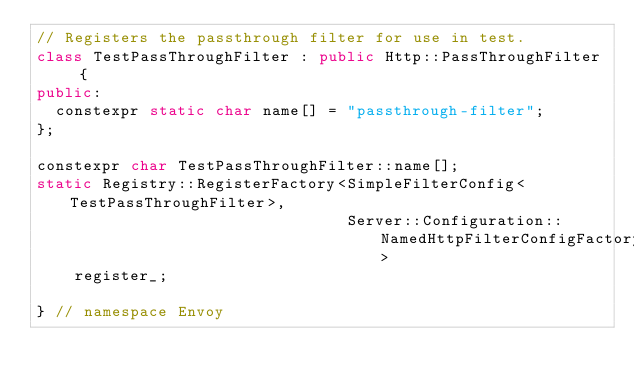Convert code to text. <code><loc_0><loc_0><loc_500><loc_500><_C++_>// Registers the passthrough filter for use in test.
class TestPassThroughFilter : public Http::PassThroughFilter {
public:
  constexpr static char name[] = "passthrough-filter";
};

constexpr char TestPassThroughFilter::name[];
static Registry::RegisterFactory<SimpleFilterConfig<TestPassThroughFilter>,
                                 Server::Configuration::NamedHttpFilterConfigFactory>
    register_;

} // namespace Envoy
</code> 